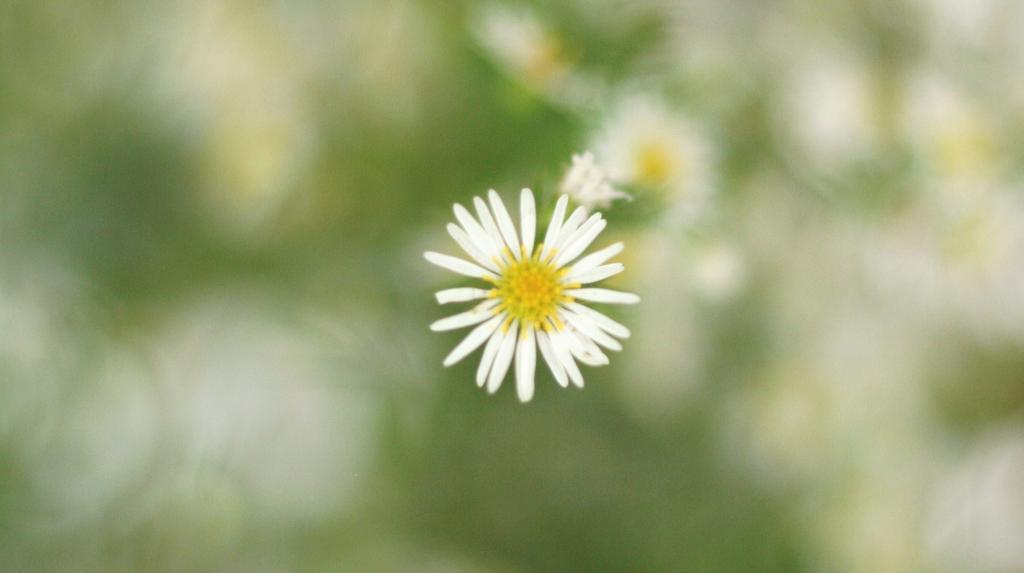Could you give a brief overview of what you see in this image? In the picture I can see the white sunflower and it is in the middle of the image. 